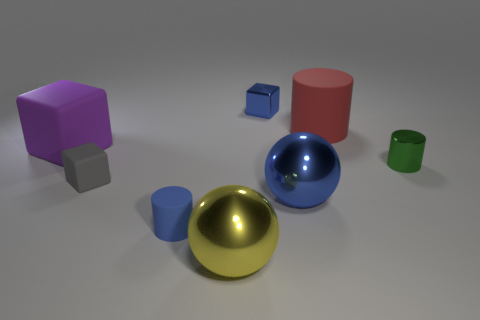What is the shape of the blue thing that is on the right side of the yellow metal thing and in front of the tiny metallic block?
Give a very brief answer. Sphere. There is another large thing that is the same material as the purple thing; what color is it?
Provide a short and direct response. Red. Are there an equal number of large objects that are right of the big purple rubber object and cubes?
Keep it short and to the point. Yes. There is a gray matte thing that is the same size as the blue shiny block; what is its shape?
Your response must be concise. Cube. How many other objects are there of the same shape as the big yellow thing?
Offer a terse response. 1. There is a purple thing; is its size the same as the cylinder left of the tiny blue shiny object?
Provide a short and direct response. No. How many objects are blue objects behind the tiny green cylinder or small cyan shiny things?
Offer a very short reply. 1. The big shiny object in front of the blue shiny ball has what shape?
Ensure brevity in your answer.  Sphere. Are there an equal number of large shiny objects in front of the big yellow shiny object and small blue rubber cylinders to the left of the purple object?
Give a very brief answer. Yes. The big thing that is on the left side of the big blue shiny ball and behind the large yellow sphere is what color?
Your response must be concise. Purple. 